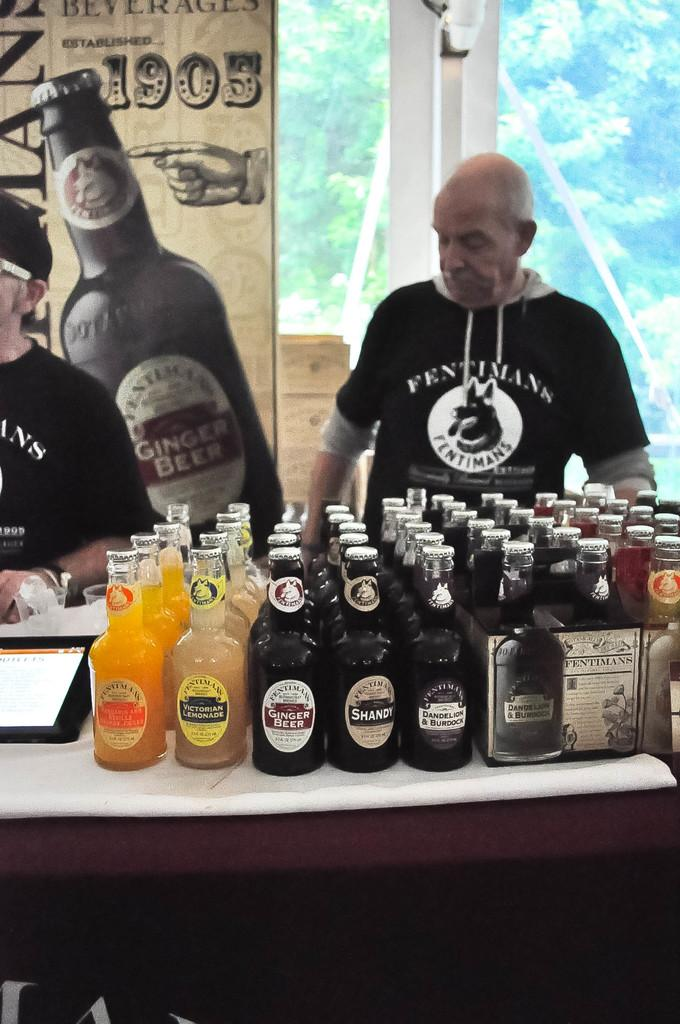Provide a one-sentence caption for the provided image. A big sign is hanging in the background with a picture of a big beer bottle and the date of 1905. 